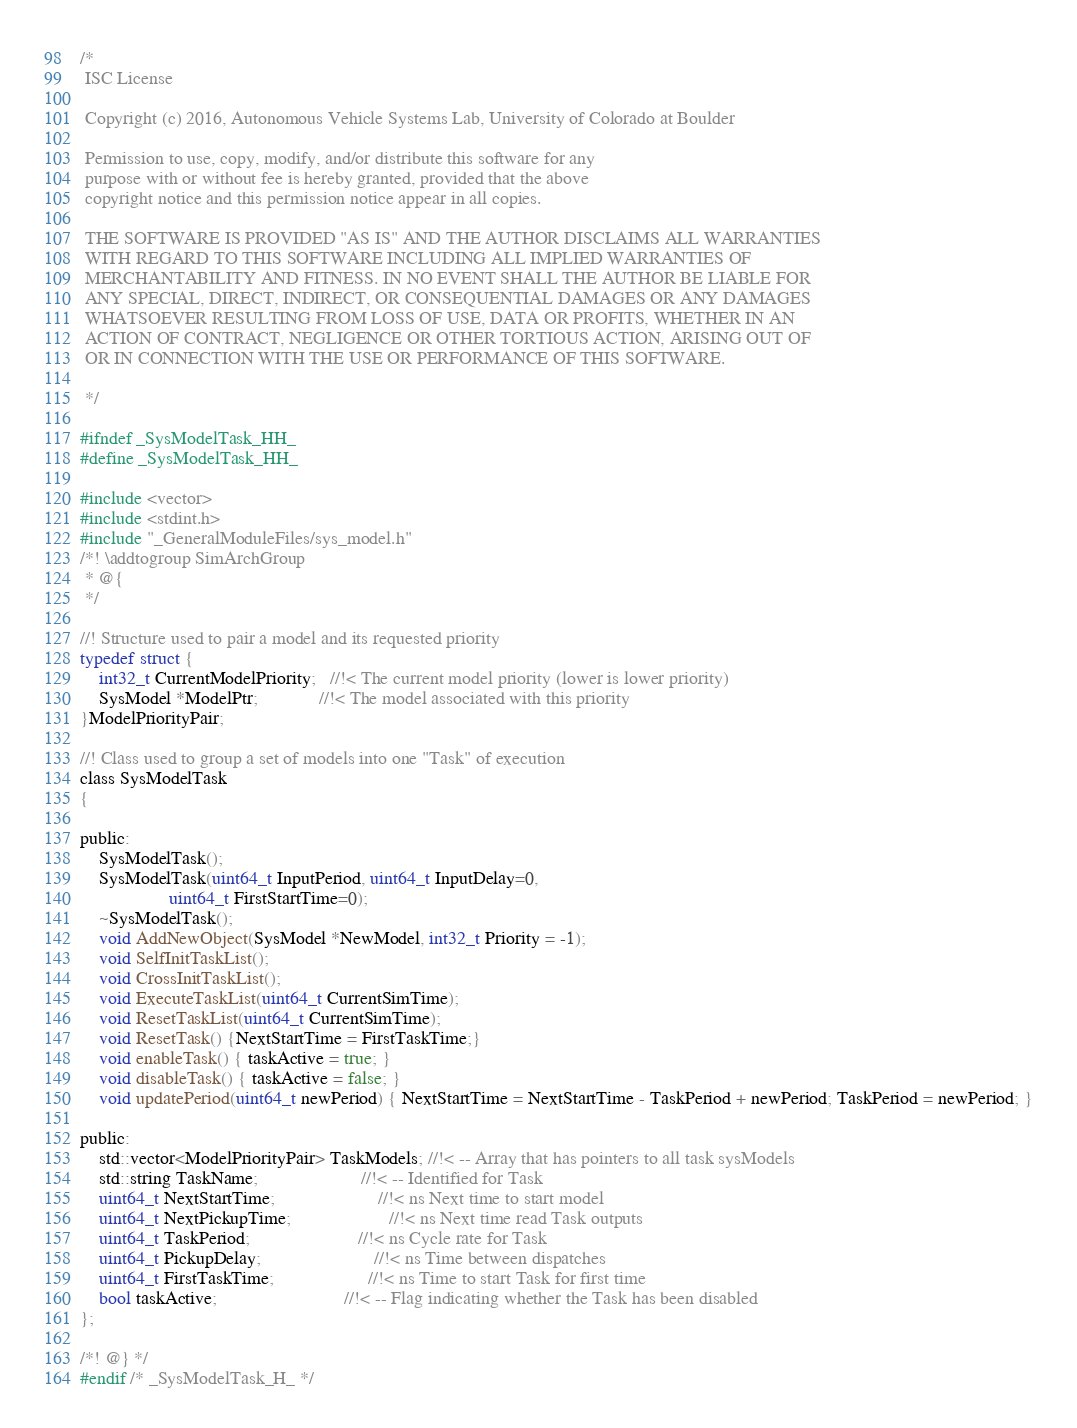<code> <loc_0><loc_0><loc_500><loc_500><_C_>/*
 ISC License

 Copyright (c) 2016, Autonomous Vehicle Systems Lab, University of Colorado at Boulder

 Permission to use, copy, modify, and/or distribute this software for any
 purpose with or without fee is hereby granted, provided that the above
 copyright notice and this permission notice appear in all copies.

 THE SOFTWARE IS PROVIDED "AS IS" AND THE AUTHOR DISCLAIMS ALL WARRANTIES
 WITH REGARD TO THIS SOFTWARE INCLUDING ALL IMPLIED WARRANTIES OF
 MERCHANTABILITY AND FITNESS. IN NO EVENT SHALL THE AUTHOR BE LIABLE FOR
 ANY SPECIAL, DIRECT, INDIRECT, OR CONSEQUENTIAL DAMAGES OR ANY DAMAGES
 WHATSOEVER RESULTING FROM LOSS OF USE, DATA OR PROFITS, WHETHER IN AN
 ACTION OF CONTRACT, NEGLIGENCE OR OTHER TORTIOUS ACTION, ARISING OUT OF
 OR IN CONNECTION WITH THE USE OR PERFORMANCE OF THIS SOFTWARE.

 */

#ifndef _SysModelTask_HH_
#define _SysModelTask_HH_

#include <vector>
#include <stdint.h>
#include "_GeneralModuleFiles/sys_model.h"
/*! \addtogroup SimArchGroup
 * @{
 */

//! Structure used to pair a model and its requested priority
typedef struct {
    int32_t CurrentModelPriority;   //!< The current model priority (lower is lower priority)
    SysModel *ModelPtr;             //!< The model associated with this priority
}ModelPriorityPair;

//! Class used to group a set of models into one "Task" of execution
class SysModelTask
{
    
public:
    SysModelTask();
    SysModelTask(uint64_t InputPeriod, uint64_t InputDelay=0,
                   uint64_t FirstStartTime=0);
    ~SysModelTask();
    void AddNewObject(SysModel *NewModel, int32_t Priority = -1);
    void SelfInitTaskList();
    void CrossInitTaskList();
    void ExecuteTaskList(uint64_t CurrentSimTime);
	void ResetTaskList(uint64_t CurrentSimTime);
    void ResetTask() {NextStartTime = FirstTaskTime;}
	void enableTask() { taskActive = true; }
	void disableTask() { taskActive = false; }
	void updatePeriod(uint64_t newPeriod) { NextStartTime = NextStartTime - TaskPeriod + newPeriod; TaskPeriod = newPeriod; }
    
public:
    std::vector<ModelPriorityPair> TaskModels; //!< -- Array that has pointers to all task sysModels
    std::string TaskName;                      //!< -- Identified for Task
    uint64_t NextStartTime;                      //!< ns Next time to start model
    uint64_t NextPickupTime;                     //!< ns Next time read Task outputs
    uint64_t TaskPeriod;                       //!< ns Cycle rate for Task
    uint64_t PickupDelay;                        //!< ns Time between dispatches
    uint64_t FirstTaskTime;                    //!< ns Time to start Task for first time
	bool taskActive;                           //!< -- Flag indicating whether the Task has been disabled 
};

/*! @} */
#endif /* _SysModelTask_H_ */
</code> 